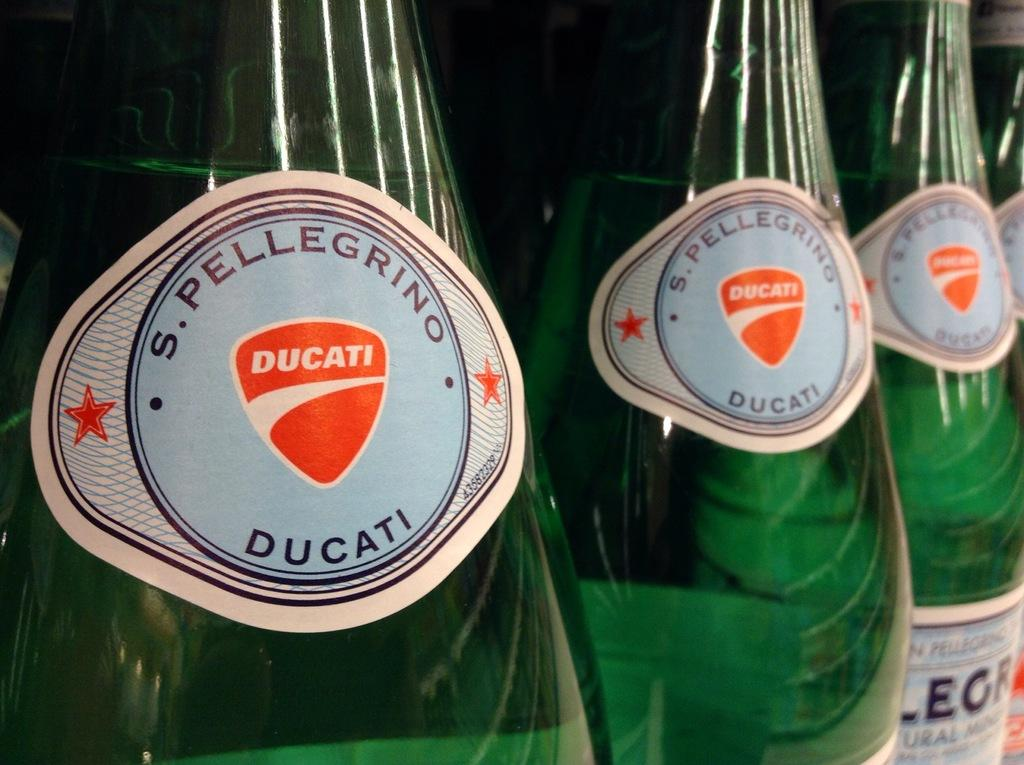Provide a one-sentence caption for the provided image. Three green bottles of S. Pelligrino Ducati lined up next to each other. 